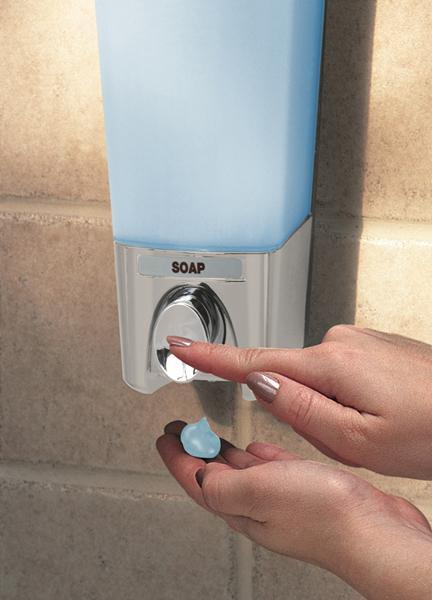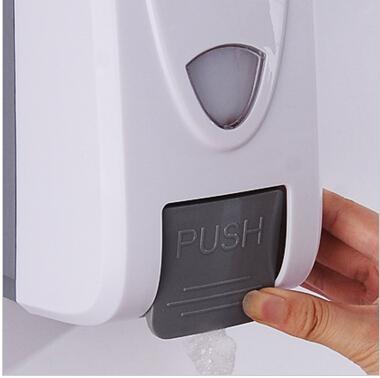The first image is the image on the left, the second image is the image on the right. Analyze the images presented: Is the assertion "In at least one image, a human hand is visible interacting with a soap dispenser" valid? Answer yes or no. Yes. The first image is the image on the left, the second image is the image on the right. Given the left and right images, does the statement "The right image contains at least two sinks." hold true? Answer yes or no. No. 